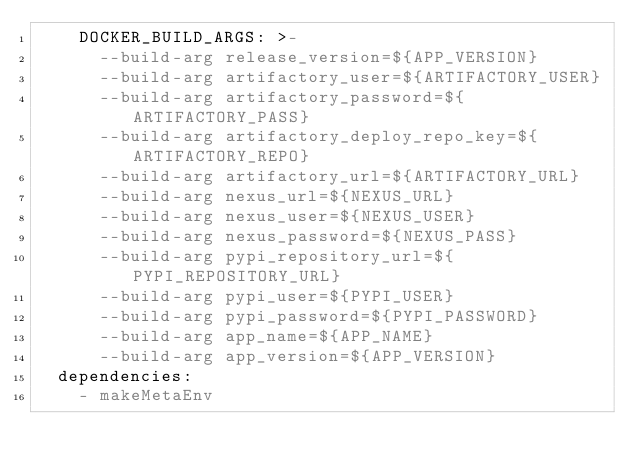<code> <loc_0><loc_0><loc_500><loc_500><_YAML_>    DOCKER_BUILD_ARGS: >-
      --build-arg release_version=${APP_VERSION}
      --build-arg artifactory_user=${ARTIFACTORY_USER}
      --build-arg artifactory_password=${ARTIFACTORY_PASS}
      --build-arg artifactory_deploy_repo_key=${ARTIFACTORY_REPO}
      --build-arg artifactory_url=${ARTIFACTORY_URL}
      --build-arg nexus_url=${NEXUS_URL}
      --build-arg nexus_user=${NEXUS_USER}
      --build-arg nexus_password=${NEXUS_PASS}
      --build-arg pypi_repository_url=${PYPI_REPOSITORY_URL}
      --build-arg pypi_user=${PYPI_USER}
      --build-arg pypi_password=${PYPI_PASSWORD}
      --build-arg app_name=${APP_NAME}
      --build-arg app_version=${APP_VERSION}
  dependencies:
    - makeMetaEnv
</code> 